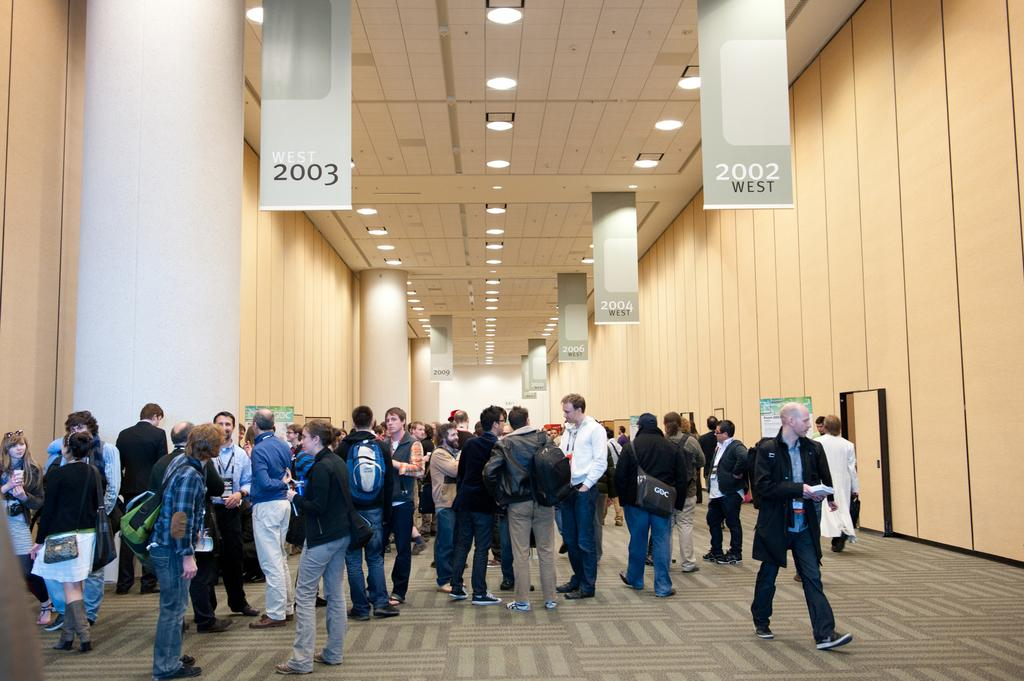What are the people in the image doing? The people in the image are standing and talking. Where are the people located? The people are in a hall. What can be seen on the ceiling in the image? There are lamps on the ceiling in the image. What decorations are hanging in the hall? There are banners hanging in the image. What type of bridge can be seen in the image? There is no bridge present in the image; the people are in a hall with lamps and banners. 